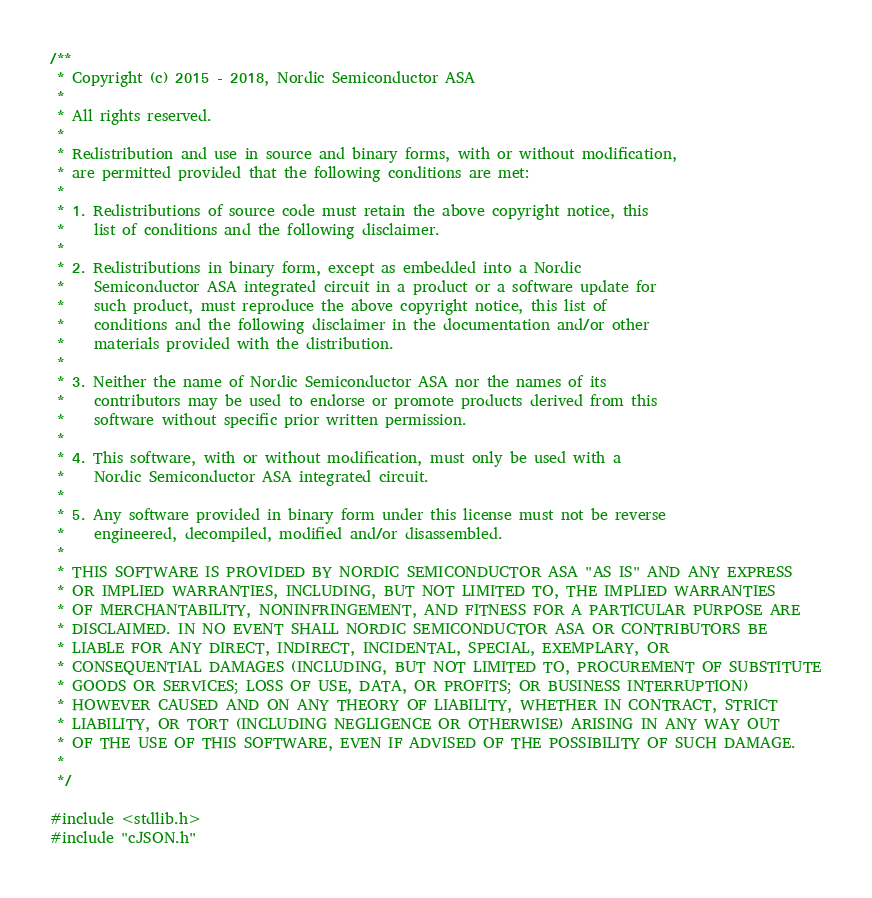Convert code to text. <code><loc_0><loc_0><loc_500><loc_500><_C_>/**
 * Copyright (c) 2015 - 2018, Nordic Semiconductor ASA
 * 
 * All rights reserved.
 * 
 * Redistribution and use in source and binary forms, with or without modification,
 * are permitted provided that the following conditions are met:
 * 
 * 1. Redistributions of source code must retain the above copyright notice, this
 *    list of conditions and the following disclaimer.
 * 
 * 2. Redistributions in binary form, except as embedded into a Nordic
 *    Semiconductor ASA integrated circuit in a product or a software update for
 *    such product, must reproduce the above copyright notice, this list of
 *    conditions and the following disclaimer in the documentation and/or other
 *    materials provided with the distribution.
 * 
 * 3. Neither the name of Nordic Semiconductor ASA nor the names of its
 *    contributors may be used to endorse or promote products derived from this
 *    software without specific prior written permission.
 * 
 * 4. This software, with or without modification, must only be used with a
 *    Nordic Semiconductor ASA integrated circuit.
 * 
 * 5. Any software provided in binary form under this license must not be reverse
 *    engineered, decompiled, modified and/or disassembled.
 * 
 * THIS SOFTWARE IS PROVIDED BY NORDIC SEMICONDUCTOR ASA "AS IS" AND ANY EXPRESS
 * OR IMPLIED WARRANTIES, INCLUDING, BUT NOT LIMITED TO, THE IMPLIED WARRANTIES
 * OF MERCHANTABILITY, NONINFRINGEMENT, AND FITNESS FOR A PARTICULAR PURPOSE ARE
 * DISCLAIMED. IN NO EVENT SHALL NORDIC SEMICONDUCTOR ASA OR CONTRIBUTORS BE
 * LIABLE FOR ANY DIRECT, INDIRECT, INCIDENTAL, SPECIAL, EXEMPLARY, OR
 * CONSEQUENTIAL DAMAGES (INCLUDING, BUT NOT LIMITED TO, PROCUREMENT OF SUBSTITUTE
 * GOODS OR SERVICES; LOSS OF USE, DATA, OR PROFITS; OR BUSINESS INTERRUPTION)
 * HOWEVER CAUSED AND ON ANY THEORY OF LIABILITY, WHETHER IN CONTRACT, STRICT
 * LIABILITY, OR TORT (INCLUDING NEGLIGENCE OR OTHERWISE) ARISING IN ANY WAY OUT
 * OF THE USE OF THIS SOFTWARE, EVEN IF ADVISED OF THE POSSIBILITY OF SUCH DAMAGE.
 * 
 */

#include <stdlib.h>
#include "cJSON.h"</code> 